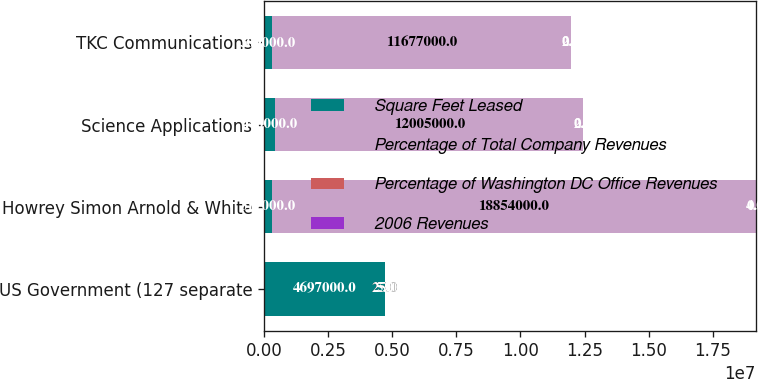Convert chart. <chart><loc_0><loc_0><loc_500><loc_500><stacked_bar_chart><ecel><fcel>US Government (127 separate<fcel>Howrey Simon Arnold & White<fcel>Science Applications<fcel>TKC Communications<nl><fcel>Square Feet Leased<fcel>4.697e+06<fcel>317000<fcel>440000<fcel>309000<nl><fcel>Percentage of Total Company Revenues<fcel>25<fcel>1.8854e+07<fcel>1.2005e+07<fcel>1.1677e+07<nl><fcel>Percentage of Washington DC Office Revenues<fcel>25<fcel>4<fcel>2<fcel>2<nl><fcel>2006 Revenues<fcel>5<fcel>0.7<fcel>0.4<fcel>0.4<nl></chart> 